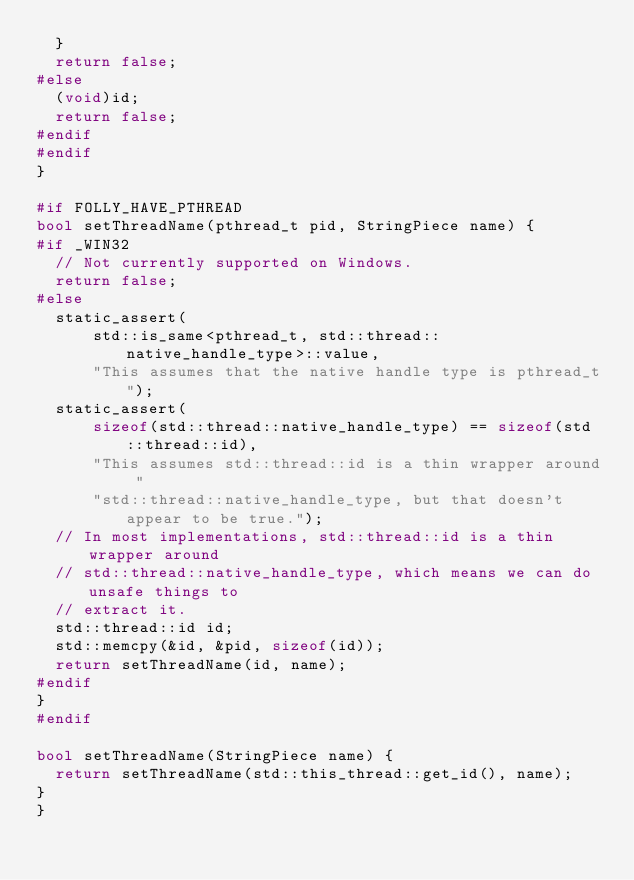Convert code to text. <code><loc_0><loc_0><loc_500><loc_500><_C++_>  }
  return false;
#else
  (void)id;
  return false;
#endif
#endif
}

#if FOLLY_HAVE_PTHREAD
bool setThreadName(pthread_t pid, StringPiece name) {
#if _WIN32
  // Not currently supported on Windows.
  return false;
#else
  static_assert(
      std::is_same<pthread_t, std::thread::native_handle_type>::value,
      "This assumes that the native handle type is pthread_t");
  static_assert(
      sizeof(std::thread::native_handle_type) == sizeof(std::thread::id),
      "This assumes std::thread::id is a thin wrapper around "
      "std::thread::native_handle_type, but that doesn't appear to be true.");
  // In most implementations, std::thread::id is a thin wrapper around
  // std::thread::native_handle_type, which means we can do unsafe things to
  // extract it.
  std::thread::id id;
  std::memcpy(&id, &pid, sizeof(id));
  return setThreadName(id, name);
#endif
}
#endif

bool setThreadName(StringPiece name) {
  return setThreadName(std::this_thread::get_id(), name);
}
}
</code> 